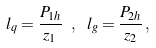Convert formula to latex. <formula><loc_0><loc_0><loc_500><loc_500>l _ { q } = \frac { P _ { 1 h } } { z _ { 1 } } \ , \ l _ { g } = \frac { P _ { 2 h } } { z _ { 2 } } \, ,</formula> 